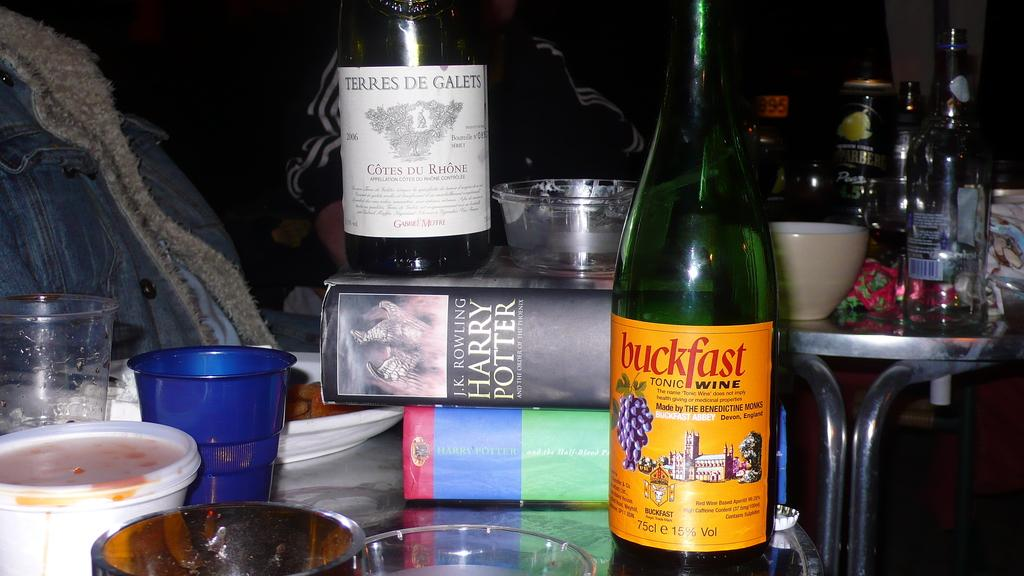<image>
Write a terse but informative summary of the picture. Two Harry Potter books with a collection of bottles including one from Buckfast. 